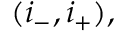Convert formula to latex. <formula><loc_0><loc_0><loc_500><loc_500>( i _ { - } , i _ { + } ) ,</formula> 